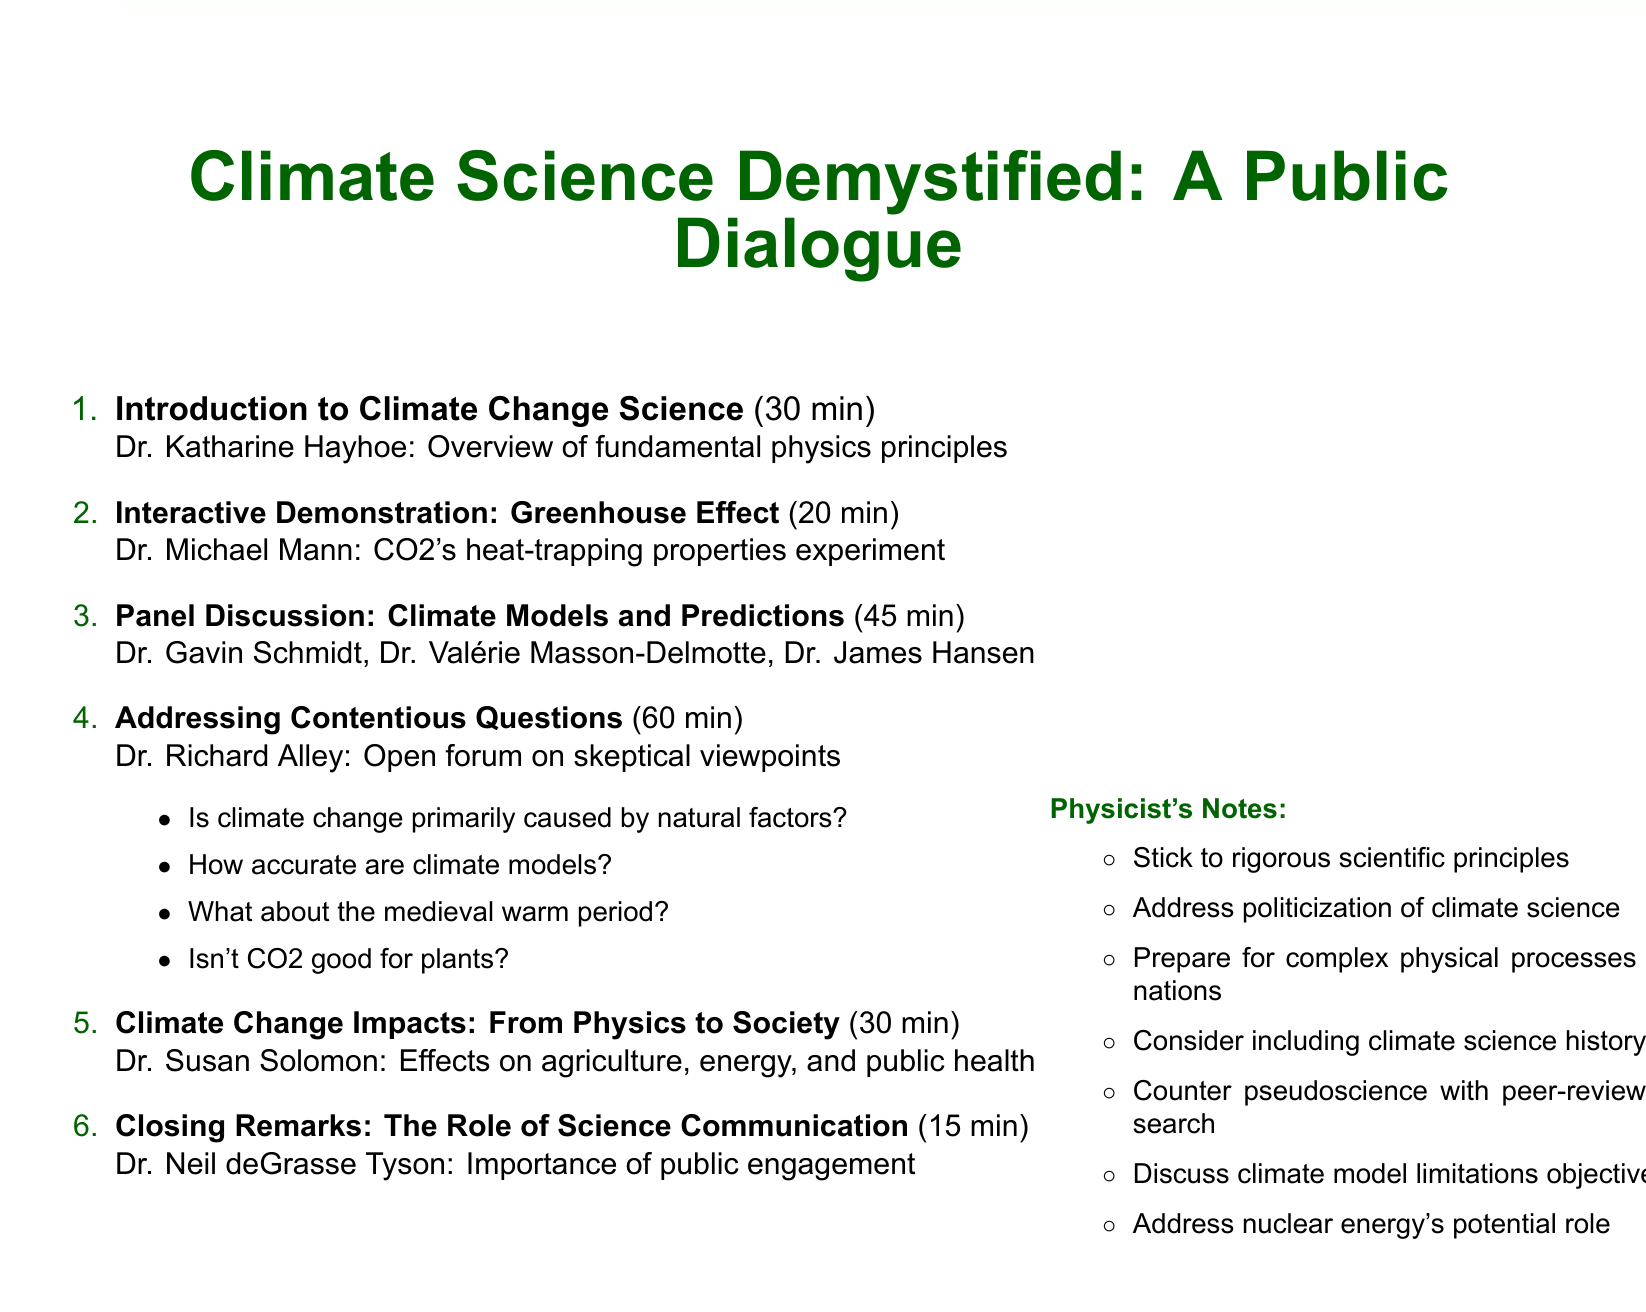What is the title of the event? The title of the event is mentioned at the beginning of the document.
Answer: Climate Science Demystified: A Public Dialogue Who is the speaker for the introduction to climate change science? The speaker's name is listed alongside the agenda item description.
Answer: Dr. Katharine Hayhoe How long is the panel discussion on climate models and predictions? The duration for this agenda item is specified explicitly in the document.
Answer: 45 minutes What is the main focus of the interactive demonstration? The description clarifies the purpose of the demonstration.
Answer: CO2's heat-trapping properties Who will moderate the session addressing contentious questions? The moderator's name is provided in the agenda item description.
Answer: Dr. Richard Alley What are the consequences addressed in the discussion on climate change impacts? The description outlines the sectors affected by climate change.
Answer: Agriculture, energy, and public health How many potential contentious questions are listed in the document? The document lists potential questions in a specific agenda item.
Answer: Four What is the duration of the closing remarks? The duration is specified clearly next to the closing remarks agenda item.
Answer: 15 minutes What kind of principles should presenters adhere to according to the physicist's notes? The notes emphasize the importance of specific principles for presentations.
Answer: Rigorous scientific principles 